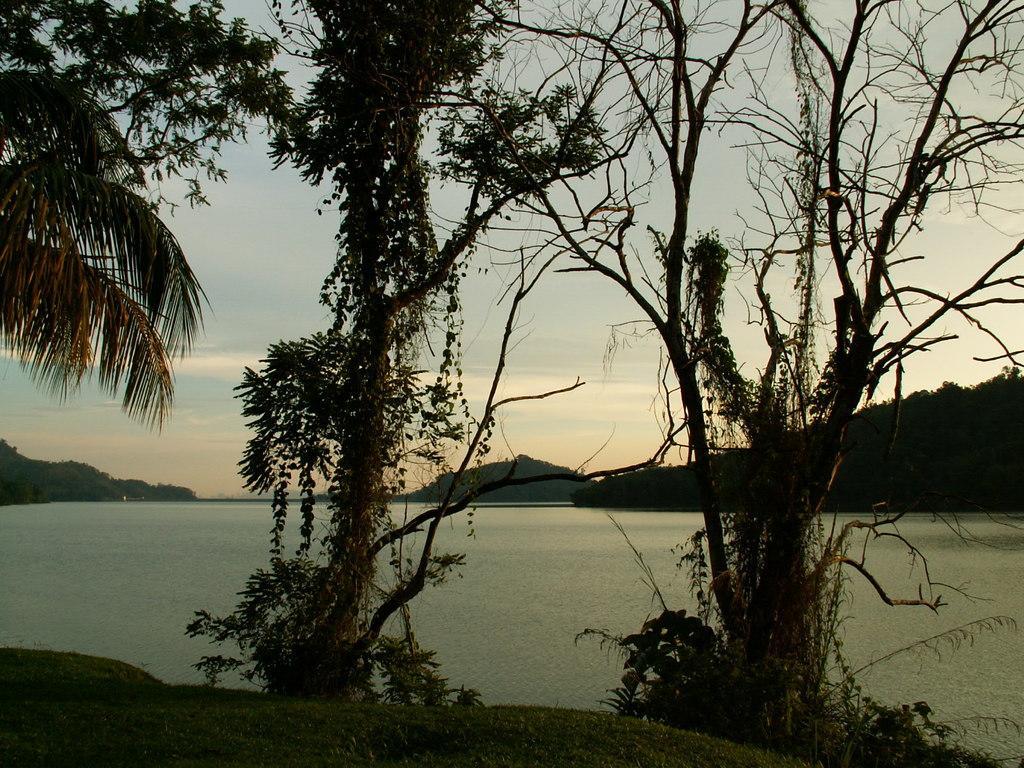How would you summarize this image in a sentence or two? In this image I can see the trees. To the side of the trees there is a water. In the background there is a mountain and the sky. 